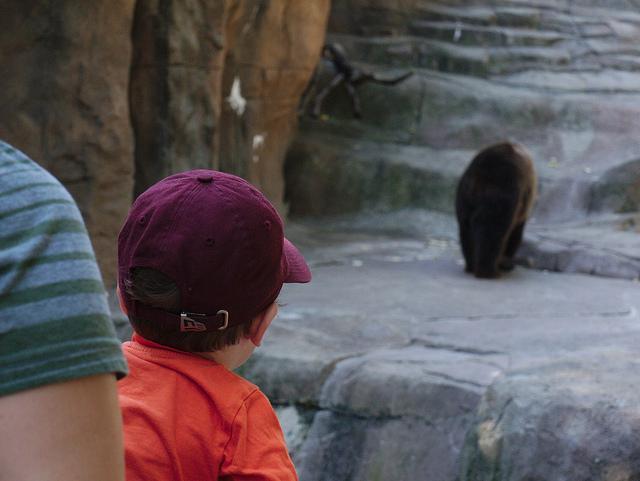Where is the boy visiting?
Answer the question by selecting the correct answer among the 4 following choices.
Options: Zoo, jungle, yard, school. Zoo. 